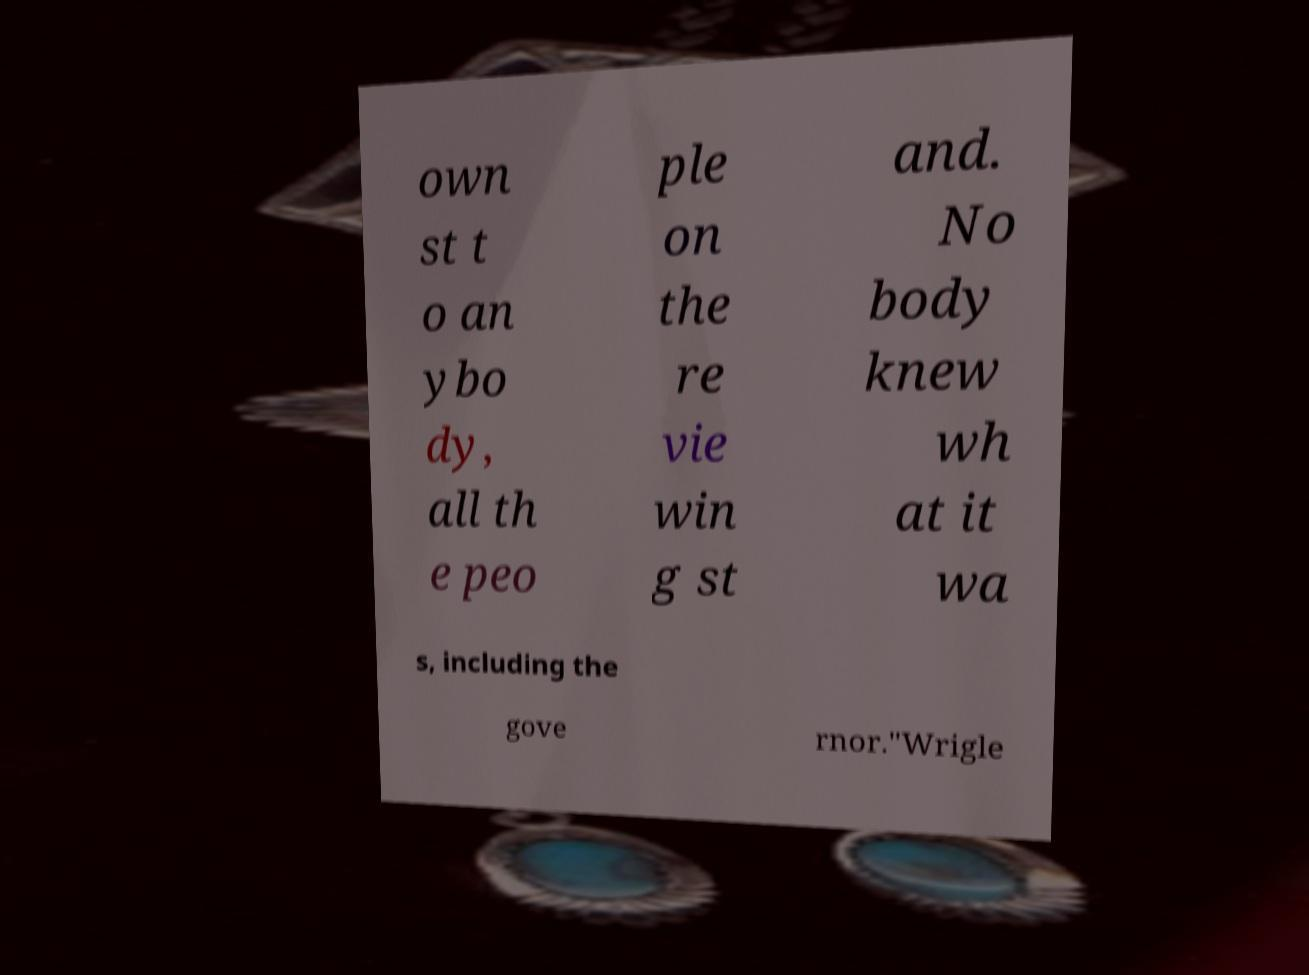Please identify and transcribe the text found in this image. own st t o an ybo dy, all th e peo ple on the re vie win g st and. No body knew wh at it wa s, including the gove rnor."Wrigle 